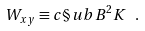<formula> <loc_0><loc_0><loc_500><loc_500>W _ { x y } \equiv c \S u b B ^ { 2 } K \ .</formula> 